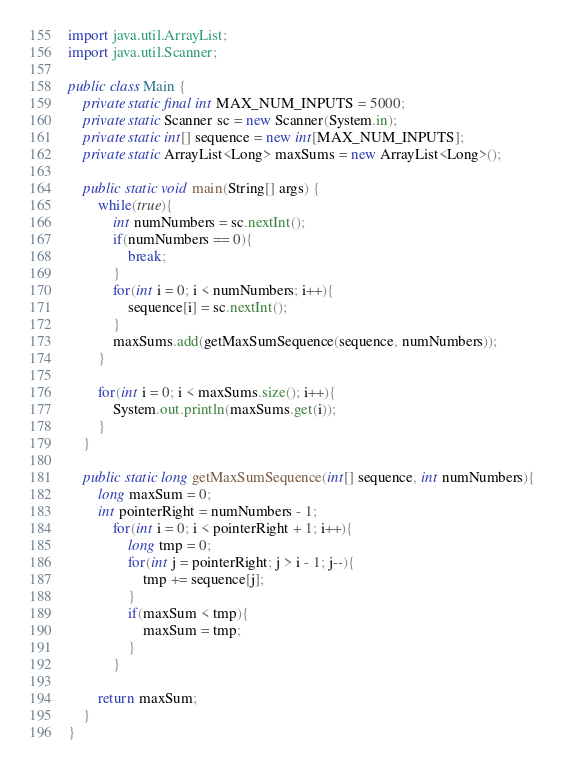Convert code to text. <code><loc_0><loc_0><loc_500><loc_500><_Java_>
import java.util.ArrayList;
import java.util.Scanner;

public class Main {
	private static final int MAX_NUM_INPUTS = 5000;
	private static Scanner sc = new Scanner(System.in);
	private static int[] sequence = new int[MAX_NUM_INPUTS];
	private static ArrayList<Long> maxSums = new ArrayList<Long>();
	
	public static void main(String[] args) {
		while(true){
			int numNumbers = sc.nextInt();
			if(numNumbers == 0){
				break;
			}
			for(int i = 0; i < numNumbers; i++){
				sequence[i] = sc.nextInt();
			}
			maxSums.add(getMaxSumSequence(sequence, numNumbers));
		}
		
		for(int i = 0; i < maxSums.size(); i++){
			System.out.println(maxSums.get(i));
		}
	}
	
	public static long getMaxSumSequence(int[] sequence, int numNumbers){
		long maxSum = 0;
		int pointerRight = numNumbers - 1;
			for(int i = 0; i < pointerRight + 1; i++){
				long tmp = 0;
				for(int j = pointerRight; j > i - 1; j--){
					tmp += sequence[j];
				}
				if(maxSum < tmp){
					maxSum = tmp;
				}
			}
		
		return maxSum;
	}
}</code> 